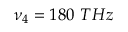Convert formula to latex. <formula><loc_0><loc_0><loc_500><loc_500>\nu _ { 4 } = 1 8 0 T H z</formula> 